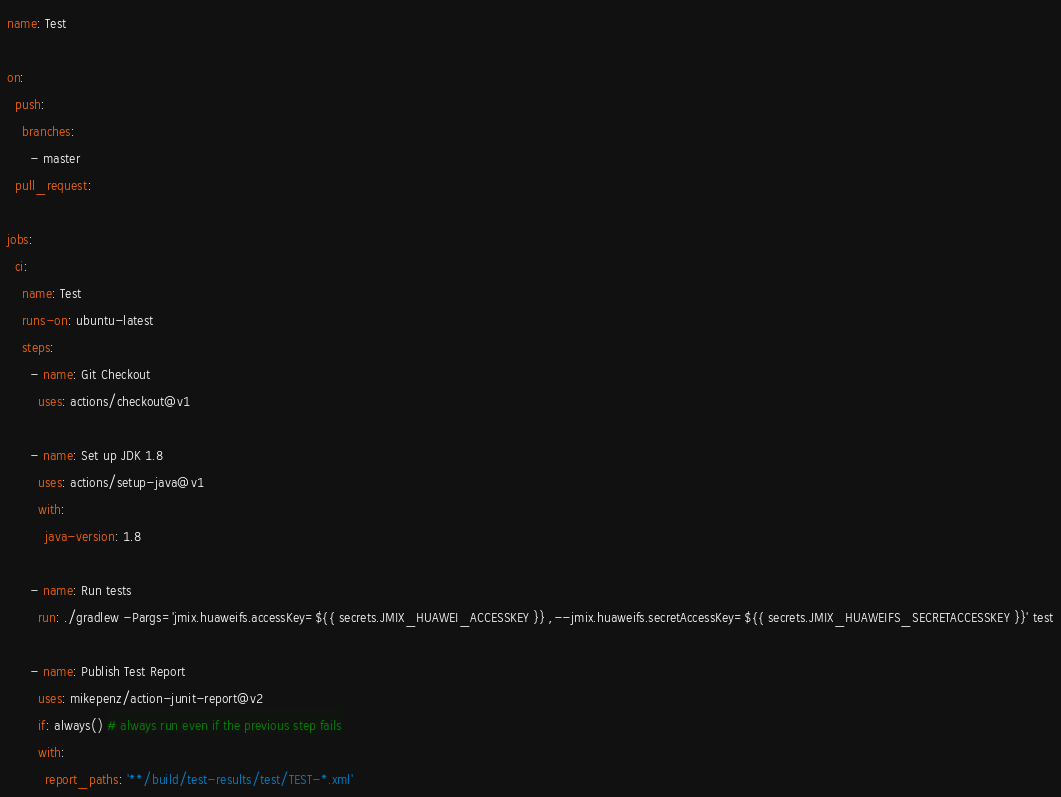<code> <loc_0><loc_0><loc_500><loc_500><_YAML_>name: Test

on:
  push:
    branches:
      - master
  pull_request:

jobs:
  ci:
    name: Test
    runs-on: ubuntu-latest
    steps:
      - name: Git Checkout
        uses: actions/checkout@v1

      - name: Set up JDK 1.8
        uses: actions/setup-java@v1
        with:
          java-version: 1.8

      - name: Run tests
        run: ./gradlew -Pargs='jmix.huaweifs.accessKey=${{ secrets.JMIX_HUAWEI_ACCESSKEY }} ,--jmix.huaweifs.secretAccessKey=${{ secrets.JMIX_HUAWEIFS_SECRETACCESSKEY }}' test

      - name: Publish Test Report
        uses: mikepenz/action-junit-report@v2
        if: always() # always run even if the previous step fails
        with:
          report_paths: '**/build/test-results/test/TEST-*.xml'</code> 